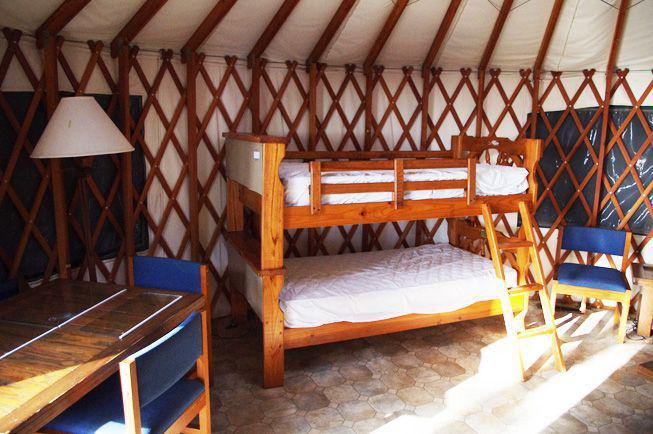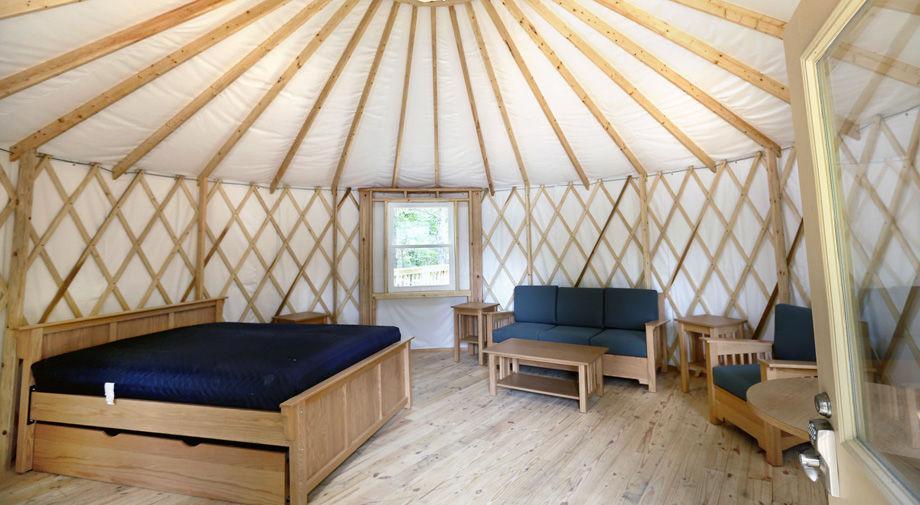The first image is the image on the left, the second image is the image on the right. Analyze the images presented: Is the assertion "One image is an interior with lattice on the walls, and the other is an exterior shot of round buildings with a tall tree present." valid? Answer yes or no. No. The first image is the image on the left, the second image is the image on the right. Evaluate the accuracy of this statement regarding the images: "In one image, at least four yurts are seen in an outdoor area with at least one tree, while a second image shows the interior of a yurt with lattice on wall area.". Is it true? Answer yes or no. No. 